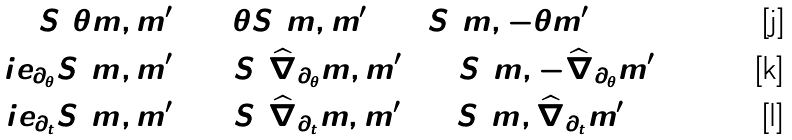Convert formula to latex. <formula><loc_0><loc_0><loc_500><loc_500>S ( \theta m , m ^ { \prime } ) & = \theta S ( m , m ^ { \prime } ) = S ( m , - \theta m ^ { \prime } ) \\ \L i e _ { \partial _ { \theta } } S ( m , m ^ { \prime } ) & = S ( \widehat { \nabla } _ { \partial _ { \theta } } m , m ^ { \prime } ) + S ( m , - \widehat { \nabla } _ { \partial _ { \theta } } m ^ { \prime } ) \\ \L i e _ { \partial _ { t } } S ( m , m ^ { \prime } ) & = S ( \widehat { \nabla } _ { \partial _ { t } } m , m ^ { \prime } ) + S ( m , \widehat { \nabla } _ { \partial _ { t } } m ^ { \prime } )</formula> 